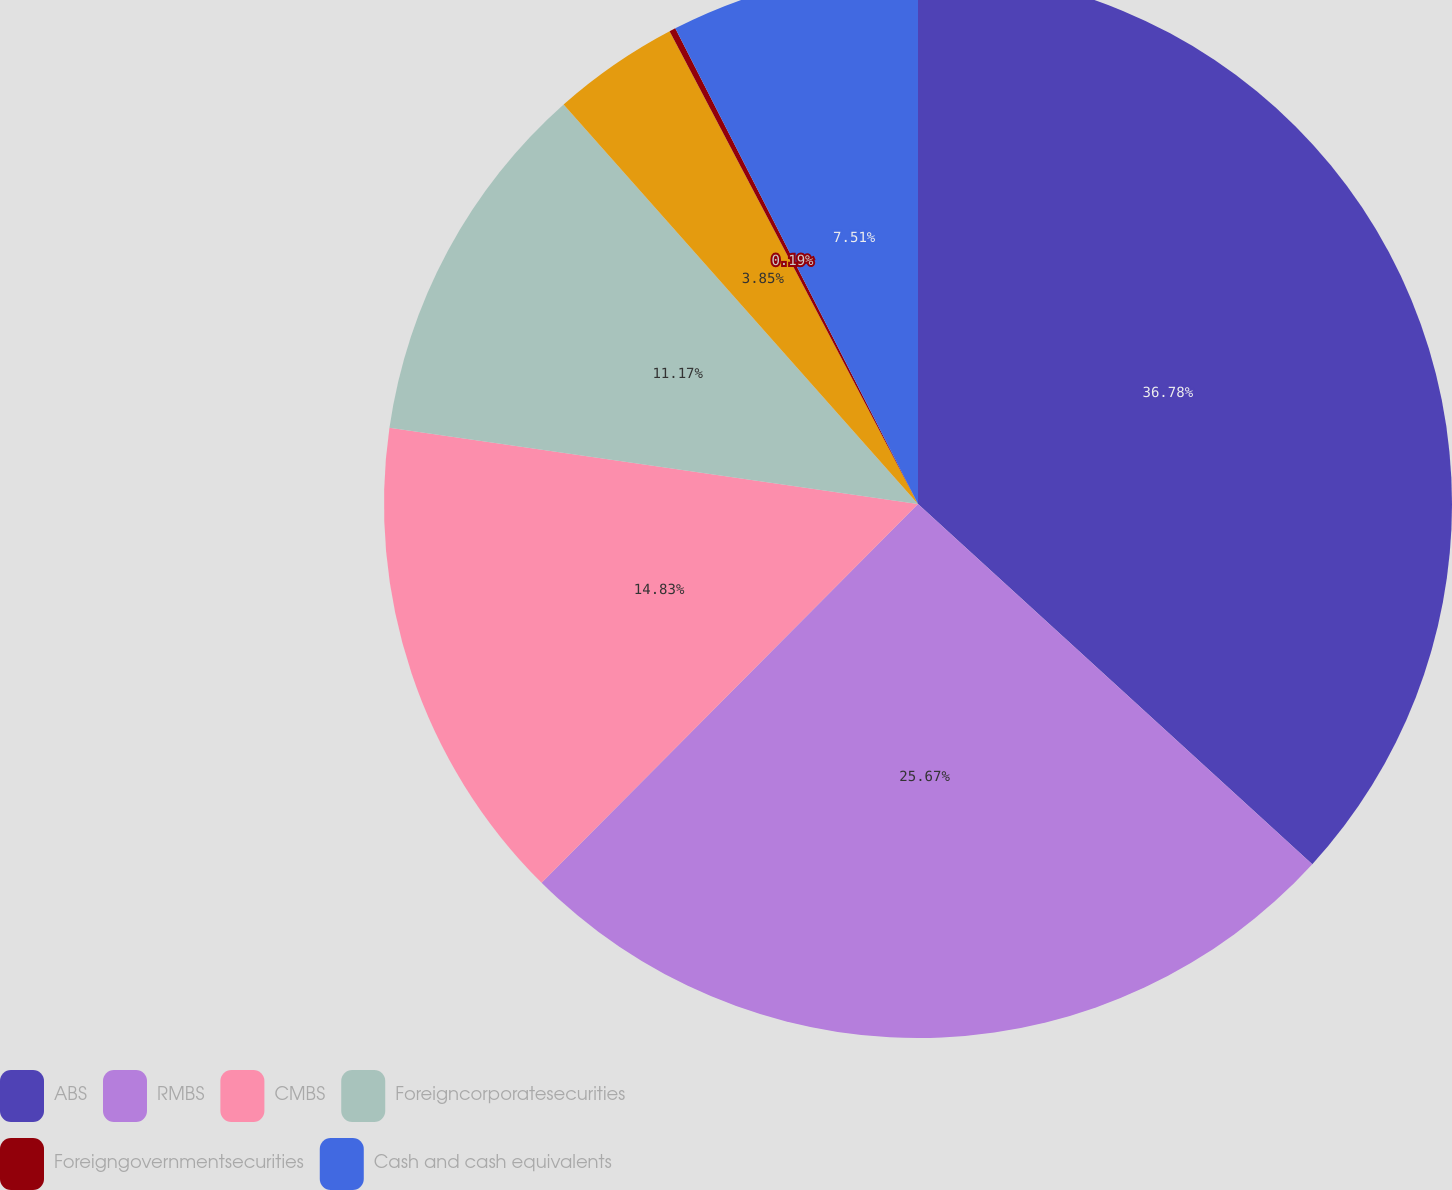Convert chart to OTSL. <chart><loc_0><loc_0><loc_500><loc_500><pie_chart><fcel>ABS<fcel>RMBS<fcel>CMBS<fcel>Foreigncorporatesecurities<fcel>Unnamed: 4<fcel>Foreigngovernmentsecurities<fcel>Cash and cash equivalents<nl><fcel>36.78%<fcel>25.67%<fcel>14.83%<fcel>11.17%<fcel>3.85%<fcel>0.19%<fcel>7.51%<nl></chart> 